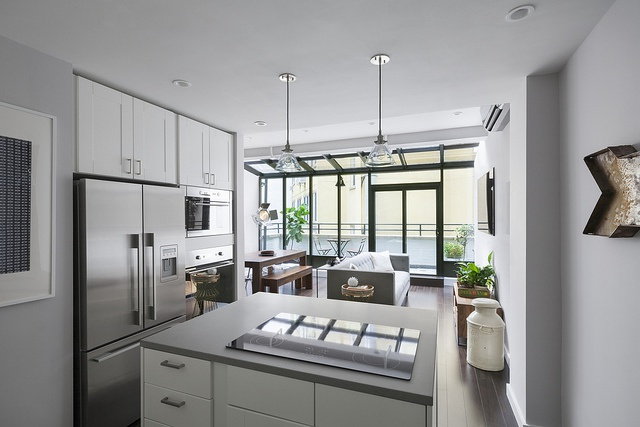Describe the objects in this image and their specific colors. I can see refrigerator in gray, darkgray, black, and lightgray tones, couch in gray, lightgray, and black tones, oven in gray, black, lightgray, and darkgray tones, oven in gray, white, black, and darkgray tones, and microwave in gray, white, black, and darkgray tones in this image. 